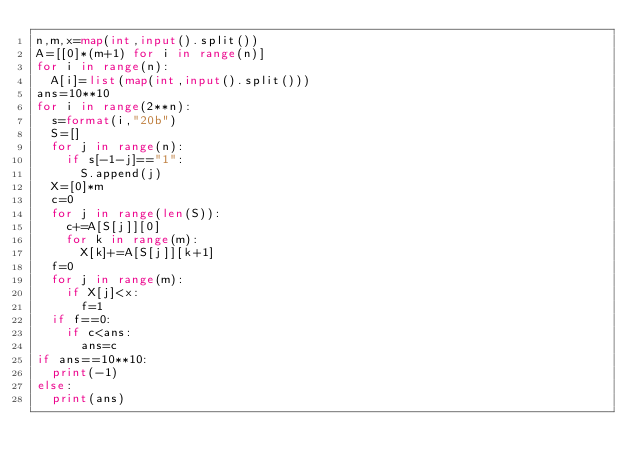<code> <loc_0><loc_0><loc_500><loc_500><_Python_>n,m,x=map(int,input().split())
A=[[0]*(m+1) for i in range(n)]
for i in range(n):
  A[i]=list(map(int,input().split()))
ans=10**10
for i in range(2**n):
  s=format(i,"20b")
  S=[]
  for j in range(n):
    if s[-1-j]=="1":
      S.append(j)
  X=[0]*m
  c=0
  for j in range(len(S)):
    c+=A[S[j]][0]
    for k in range(m):
      X[k]+=A[S[j]][k+1]
  f=0
  for j in range(m):
    if X[j]<x:
      f=1
  if f==0:
    if c<ans:
      ans=c
if ans==10**10:
  print(-1)
else:
  print(ans)</code> 